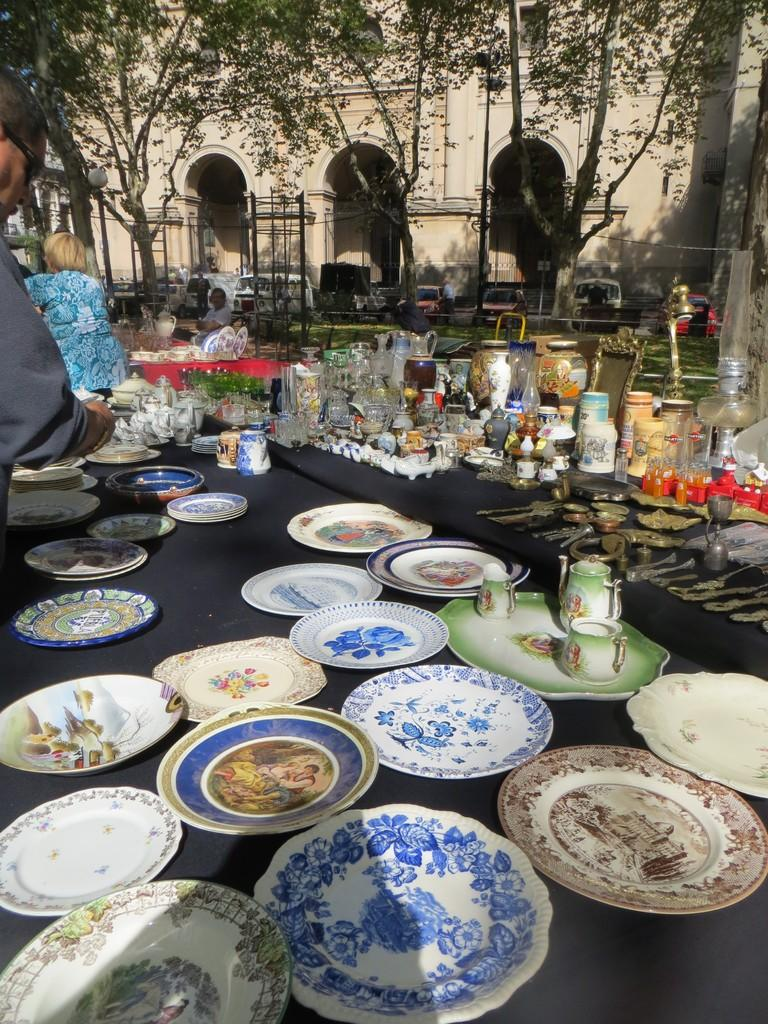What objects are present on the table in the image? There are plates, tea cups, glasses, frames, and spoons on the table. What can be inferred about the setting from the objects on the table? The objects on the table suggest that it might be a dining or gathering area. What is visible in the background of the image? There are people, trees, vehicles, and buildings in the background of the image. What type of slave is depicted in the image? There is no depiction of a slave in the image; it features a table with various objects and a background with people, trees, vehicles, and buildings. 